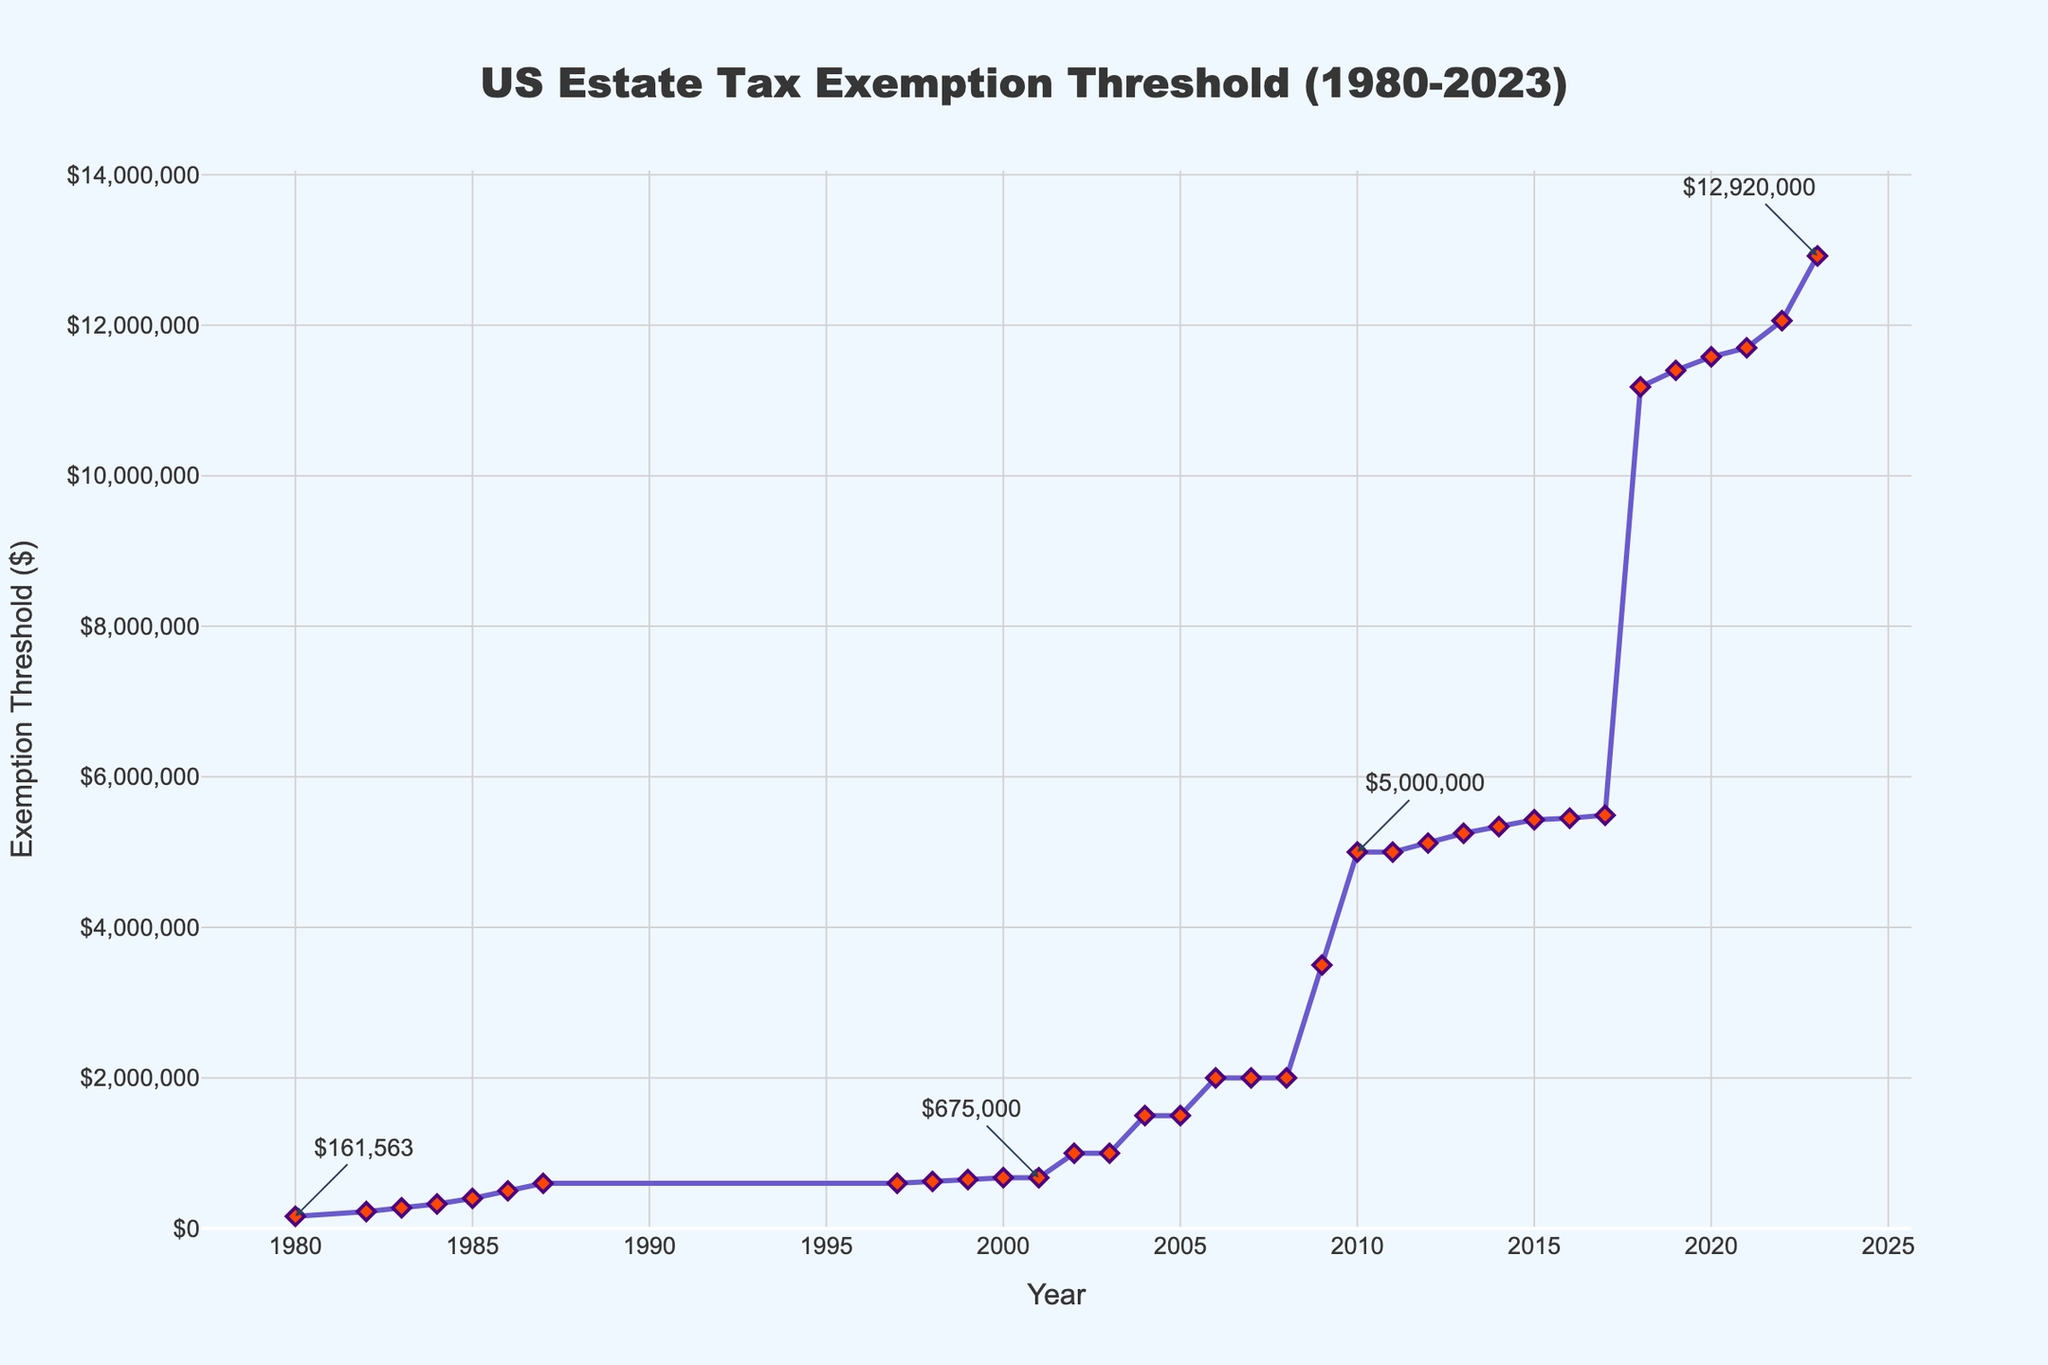What was the estate tax exemption threshold in 1980? Referring to the figure, the year 1980 shows the estate tax exemption threshold annotation as $161,563.
Answer: $161,563 How much did the estate tax exemption threshold increase from 2001 to 2010? In 2001, the threshold was $675,000, and by 2010, it was $5,000,000. The increase is calculated as $5,000,000 - $675,000.
Answer: $4,325,000 During which year did the estate tax exemption threshold first reach $1,000,000? Referring to the figure, the threshold first reached $1,000,000 in the year 2002, as seen in the data points.
Answer: 2002 What is the total increase in the estate tax exemption threshold from 1980 to 2023? In 1980, the threshold was $161,563, and by 2023, it reached $12,920,000. The total increase is calculated as $12,920,000 - $161,563.
Answer: $12,758,437 What was the estate tax exemption threshold between 1987 and 1997? Referring to the figure, the threshold remained constant at $600,000 from 1987 to 1997, as seen in the data points.
Answer: $600,000 Between which two consecutive years did the estate tax exemption threshold experience the largest increase? The largest consecutive year increase occurred between 2017 and 2018. The threshold increased from $5,490,000 in 2017 to $11,180,000 in 2018, resulting in an increase of $5,690,000.
Answer: 2017 and 2018 Compare the estate tax exemption thresholds of the years 1986 and 2002. Which year had a higher threshold? In 1986, the threshold was $500,000, and in 2002, it was $1,000,000. The year 2002 had a higher threshold.
Answer: 2002 What was the difference in the estate tax exemption thresholds between 2008 and 2009? In 2008, the threshold was $2,000,000, and in 2009, it was $3,500,000. The difference is calculated as $3,500,000 - $2,000,000.
Answer: $1,500,000 What color are the markers used to denote the estate tax exemption thresholds on the line? Referring to the visual attributes in the figure, the markers are diamond-shaped and colored red.
Answer: Red 